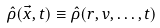Convert formula to latex. <formula><loc_0><loc_0><loc_500><loc_500>\hat { \rho } ( \vec { x } , t ) \equiv \hat { \rho } ( r , v , \dots , t )</formula> 